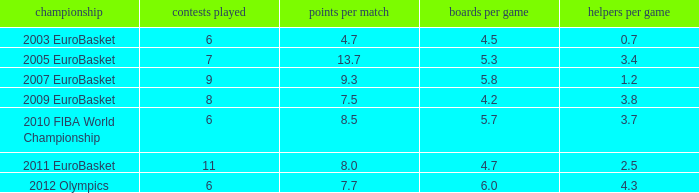How many assists per game in the tournament 2010 fiba world championship? 3.7. 